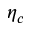<formula> <loc_0><loc_0><loc_500><loc_500>\eta _ { c }</formula> 